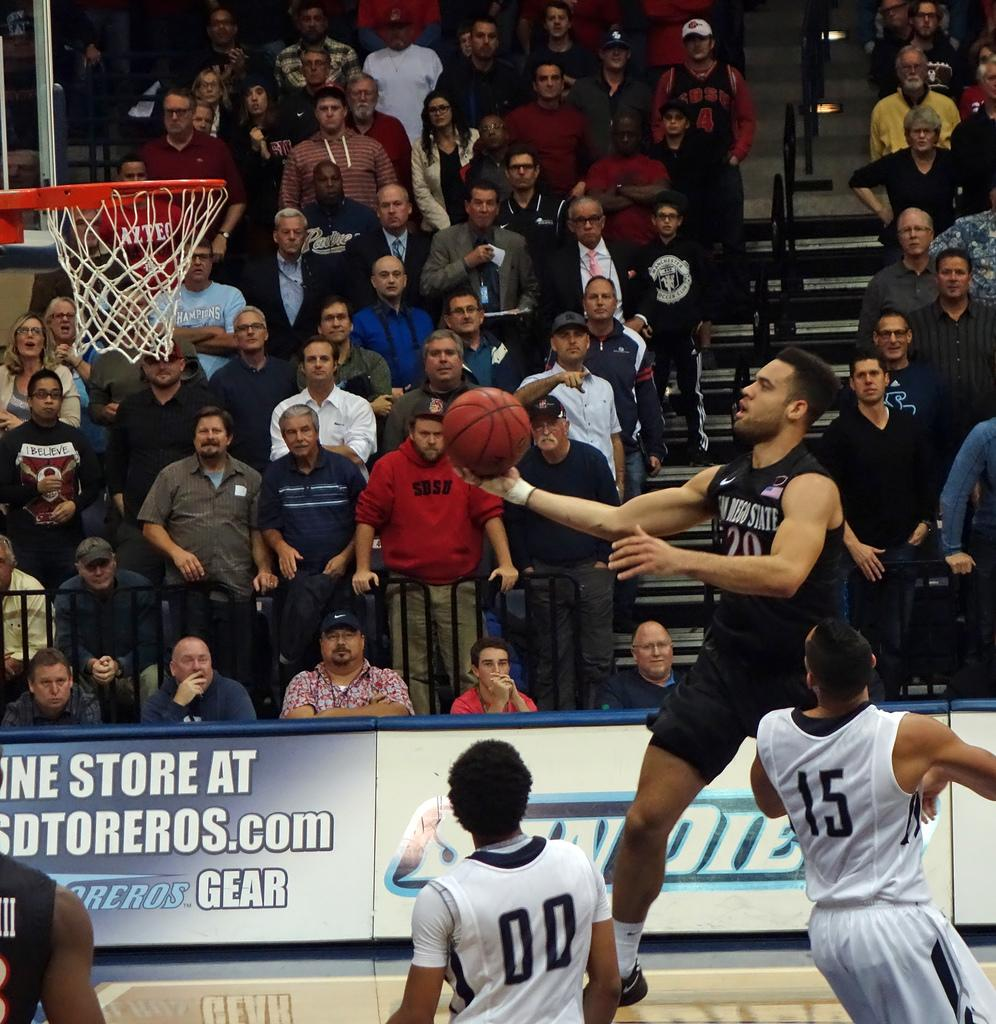<image>
Give a short and clear explanation of the subsequent image. The word gear is on one of the ads that rings this basketball court. 